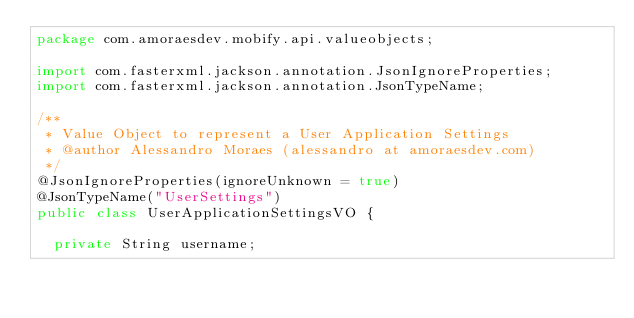<code> <loc_0><loc_0><loc_500><loc_500><_Java_>package com.amoraesdev.mobify.api.valueobjects;

import com.fasterxml.jackson.annotation.JsonIgnoreProperties;
import com.fasterxml.jackson.annotation.JsonTypeName;

/**
 * Value Object to represent a User Application Settings
 * @author Alessandro Moraes (alessandro at amoraesdev.com)
 */
@JsonIgnoreProperties(ignoreUnknown = true)
@JsonTypeName("UserSettings")
public class UserApplicationSettingsVO {

	private String username;
	</code> 